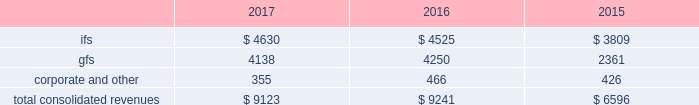2022 expand client relationships - the overall market we serve continues to gravitate beyond single-application purchases to multi-solution partnerships .
As the market dynamics shift , we expect our clients and prospects to rely more on our multidimensional service offerings .
Our leveraged solutions and processing expertise can produce meaningful value and cost savings for our clients through more efficient operating processes , improved service quality and convenience for our clients' customers .
2022 build global diversification - we continue to deploy resources in global markets where we expect to achieve meaningful scale .
Revenues by segment the table below summarizes our revenues by reporting segment ( in millions ) : .
Integrated financial solutions ( "ifs" ) the ifs segment is focused primarily on serving north american regional and community bank and savings institutions for transaction and account processing , payment solutions , channel solutions , digital channels , fraud , risk management and compliance solutions , lending and wealth and retirement solutions , and corporate liquidity , capitalizing on the continuing trend to outsource these solutions .
Clients in this segment include regional and community banks , credit unions and commercial lenders , as well as government institutions , merchants and other commercial organizations .
These markets are primarily served through integrated solutions and characterized by multi-year processing contracts that generate highly recurring revenues .
The predictable nature of cash flows generated from this segment provides opportunities for further investments in innovation , integration , information and security , and compliance in a cost-effective manner .
Our solutions in this segment include : 2022 core processing and ancillary applications .
Our core processing software applications are designed to run banking processes for our financial institution clients , including deposit and lending systems , customer management , and other central management systems , serving as the system of record for processed activity .
Our diverse selection of market- focused core systems enables fis to compete effectively in a wide range of markets .
We also offer a number of services that are ancillary to the primary applications listed above , including branch automation , back-office support systems and compliance support .
2022 digital solutions , including internet , mobile and ebanking .
Our comprehensive suite of retail delivery applications enables financial institutions to integrate and streamline customer-facing operations and back-office processes , thereby improving customer interaction across all channels ( e.g. , branch offices , internet , atm , mobile , call centers ) .
Fis' focus on consumer access has driven significant market innovation in this area , with multi-channel and multi-host solutions and a strategy that provides tight integration of services and a seamless customer experience .
Fis is a leader in mobile banking solutions and electronic banking enabling clients to manage banking and payments through the internet , mobile devices , accounting software and telephone .
Our corporate electronic banking solutions provide commercial treasury capabilities including cash management services and multi-bank collection and disbursement services that address the specialized needs of corporate clients .
Fis systems provide full accounting and reconciliation for such transactions , serving also as the system of record. .
What percentage of total consolidated revenues was gfs segment in 2017? 
Computations: (4138 / 9123)
Answer: 0.45358. 